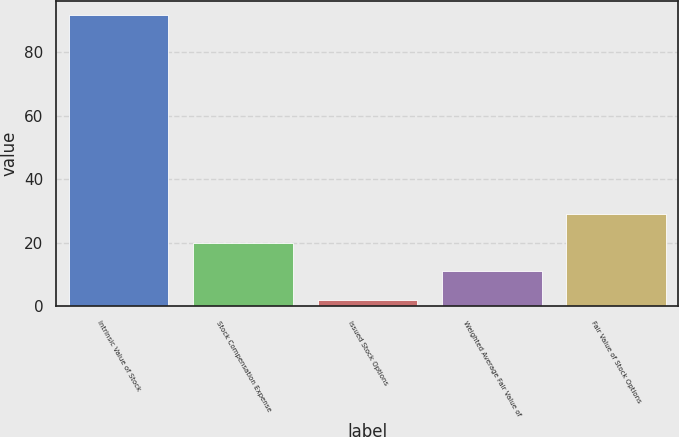Convert chart. <chart><loc_0><loc_0><loc_500><loc_500><bar_chart><fcel>Intrinsic Value of Stock<fcel>Stock Compensation Expense<fcel>Issued Stock Options<fcel>Weighted Average Fair Value of<fcel>Fair Value of Stock Options<nl><fcel>91.5<fcel>19.98<fcel>2.1<fcel>11.04<fcel>28.92<nl></chart> 